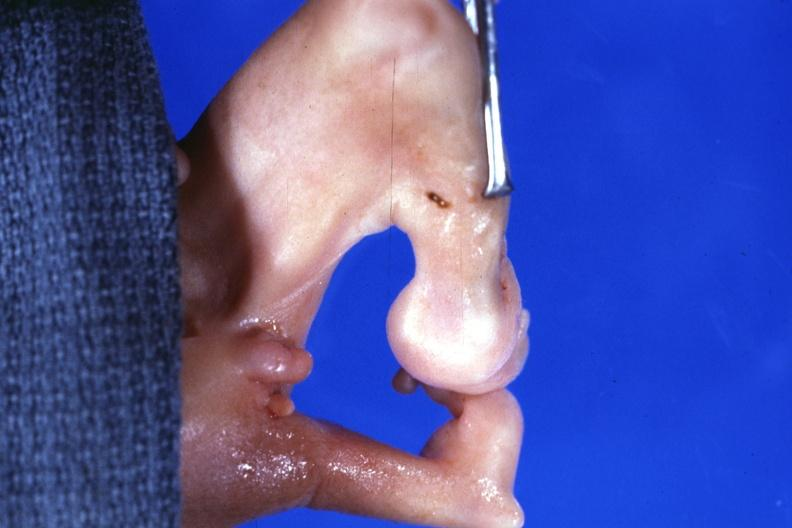what does this image show?
Answer the question using a single word or phrase. This 